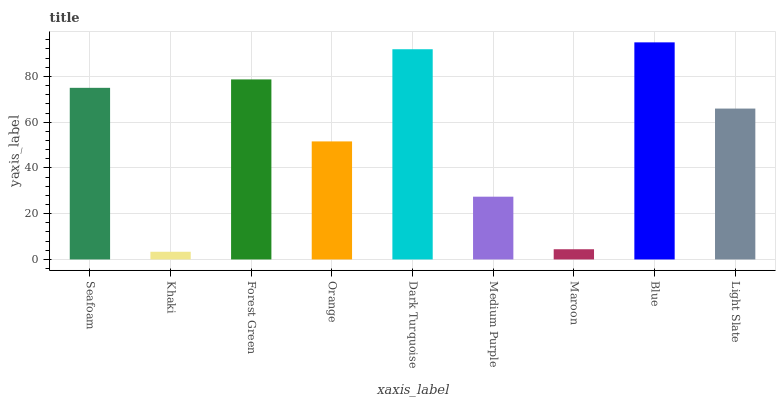Is Khaki the minimum?
Answer yes or no. Yes. Is Blue the maximum?
Answer yes or no. Yes. Is Forest Green the minimum?
Answer yes or no. No. Is Forest Green the maximum?
Answer yes or no. No. Is Forest Green greater than Khaki?
Answer yes or no. Yes. Is Khaki less than Forest Green?
Answer yes or no. Yes. Is Khaki greater than Forest Green?
Answer yes or no. No. Is Forest Green less than Khaki?
Answer yes or no. No. Is Light Slate the high median?
Answer yes or no. Yes. Is Light Slate the low median?
Answer yes or no. Yes. Is Maroon the high median?
Answer yes or no. No. Is Orange the low median?
Answer yes or no. No. 